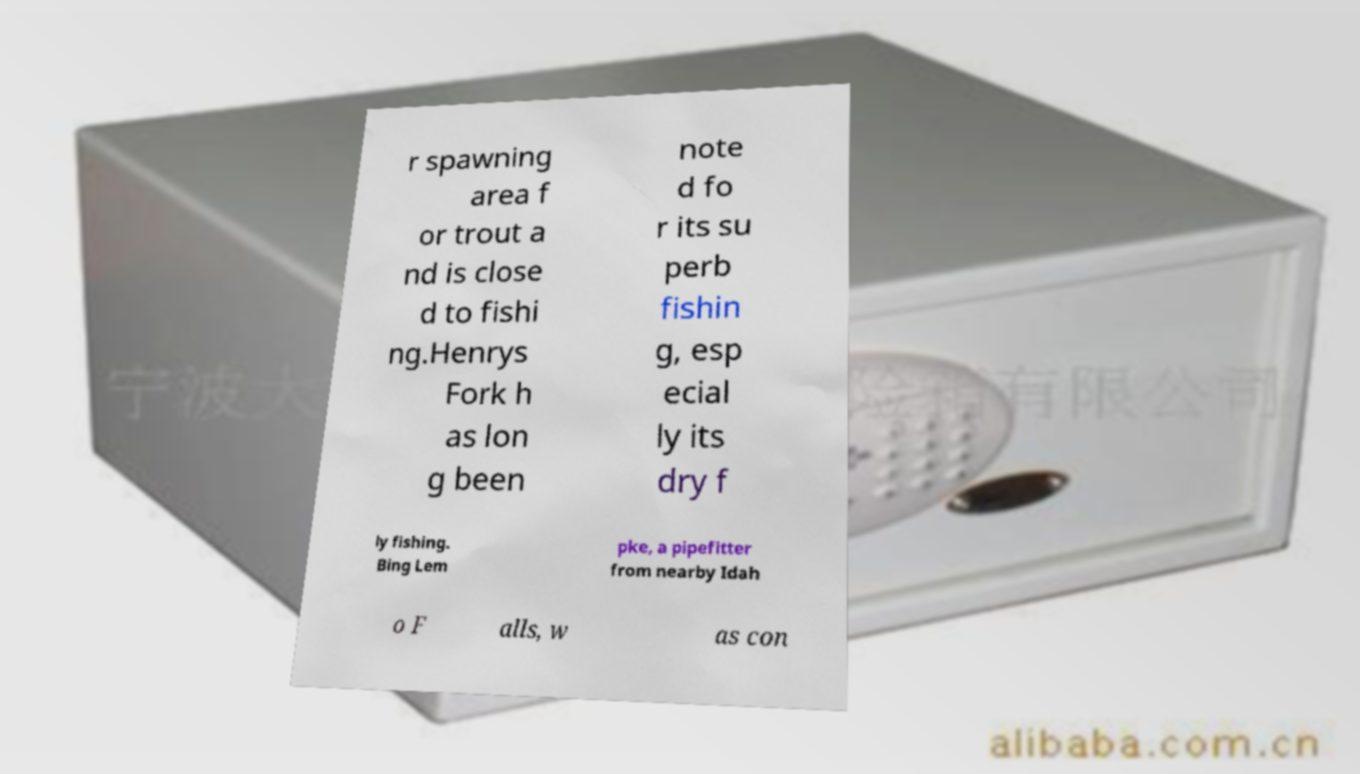There's text embedded in this image that I need extracted. Can you transcribe it verbatim? r spawning area f or trout a nd is close d to fishi ng.Henrys Fork h as lon g been note d fo r its su perb fishin g, esp ecial ly its dry f ly fishing. Bing Lem pke, a pipefitter from nearby Idah o F alls, w as con 